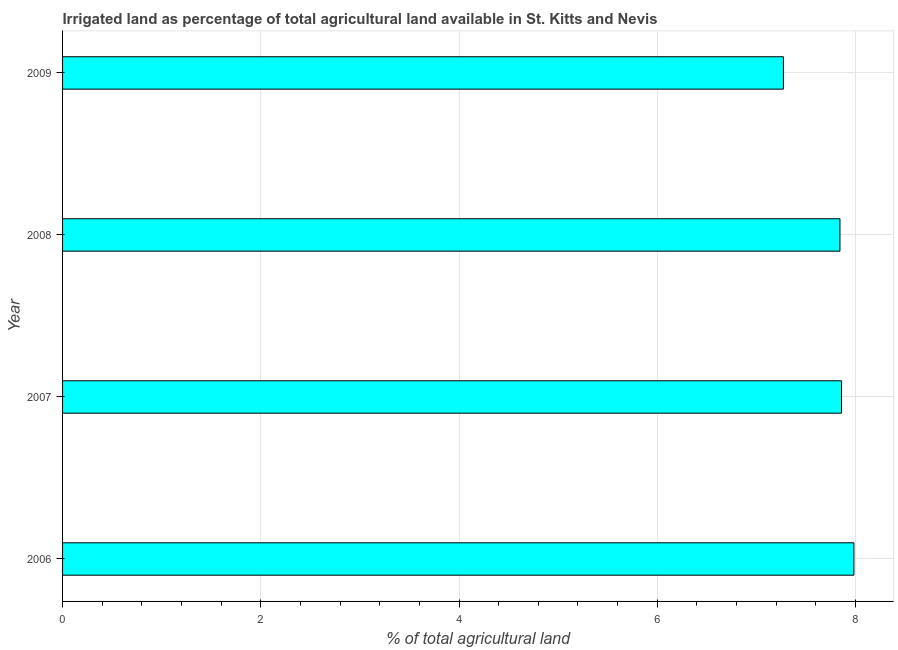Does the graph contain grids?
Provide a succinct answer. Yes. What is the title of the graph?
Ensure brevity in your answer.  Irrigated land as percentage of total agricultural land available in St. Kitts and Nevis. What is the label or title of the X-axis?
Your response must be concise. % of total agricultural land. What is the label or title of the Y-axis?
Your response must be concise. Year. What is the percentage of agricultural irrigated land in 2006?
Provide a succinct answer. 7.98. Across all years, what is the maximum percentage of agricultural irrigated land?
Make the answer very short. 7.98. Across all years, what is the minimum percentage of agricultural irrigated land?
Your answer should be compact. 7.27. In which year was the percentage of agricultural irrigated land minimum?
Give a very brief answer. 2009. What is the sum of the percentage of agricultural irrigated land?
Provide a short and direct response. 30.96. What is the difference between the percentage of agricultural irrigated land in 2007 and 2008?
Give a very brief answer. 0.01. What is the average percentage of agricultural irrigated land per year?
Offer a terse response. 7.74. What is the median percentage of agricultural irrigated land?
Ensure brevity in your answer.  7.85. Do a majority of the years between 2006 and 2007 (inclusive) have percentage of agricultural irrigated land greater than 0.8 %?
Give a very brief answer. Yes. Is the percentage of agricultural irrigated land in 2007 less than that in 2009?
Provide a short and direct response. No. Is the difference between the percentage of agricultural irrigated land in 2008 and 2009 greater than the difference between any two years?
Your answer should be compact. No. What is the difference between the highest and the lowest percentage of agricultural irrigated land?
Offer a terse response. 0.71. In how many years, is the percentage of agricultural irrigated land greater than the average percentage of agricultural irrigated land taken over all years?
Your response must be concise. 3. Are all the bars in the graph horizontal?
Keep it short and to the point. Yes. How many years are there in the graph?
Your answer should be compact. 4. What is the difference between two consecutive major ticks on the X-axis?
Make the answer very short. 2. What is the % of total agricultural land in 2006?
Give a very brief answer. 7.98. What is the % of total agricultural land of 2007?
Offer a very short reply. 7.86. What is the % of total agricultural land of 2008?
Provide a succinct answer. 7.84. What is the % of total agricultural land of 2009?
Your response must be concise. 7.27. What is the difference between the % of total agricultural land in 2006 and 2007?
Your answer should be compact. 0.13. What is the difference between the % of total agricultural land in 2006 and 2008?
Your response must be concise. 0.14. What is the difference between the % of total agricultural land in 2006 and 2009?
Provide a short and direct response. 0.71. What is the difference between the % of total agricultural land in 2007 and 2008?
Provide a short and direct response. 0.02. What is the difference between the % of total agricultural land in 2007 and 2009?
Provide a short and direct response. 0.59. What is the difference between the % of total agricultural land in 2008 and 2009?
Your response must be concise. 0.57. What is the ratio of the % of total agricultural land in 2006 to that in 2007?
Offer a terse response. 1.02. What is the ratio of the % of total agricultural land in 2006 to that in 2008?
Offer a very short reply. 1.02. What is the ratio of the % of total agricultural land in 2006 to that in 2009?
Provide a short and direct response. 1.1. What is the ratio of the % of total agricultural land in 2007 to that in 2009?
Ensure brevity in your answer.  1.08. What is the ratio of the % of total agricultural land in 2008 to that in 2009?
Your response must be concise. 1.08. 